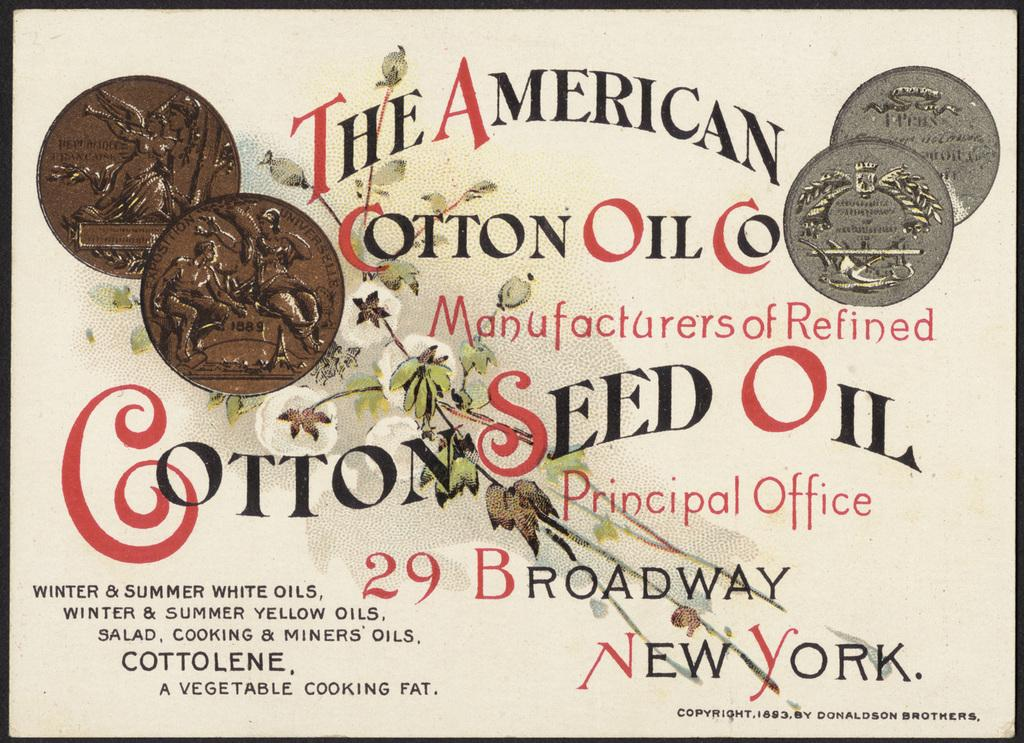<image>
Relay a brief, clear account of the picture shown. A sign advertises the American Cotton Oil Company. 